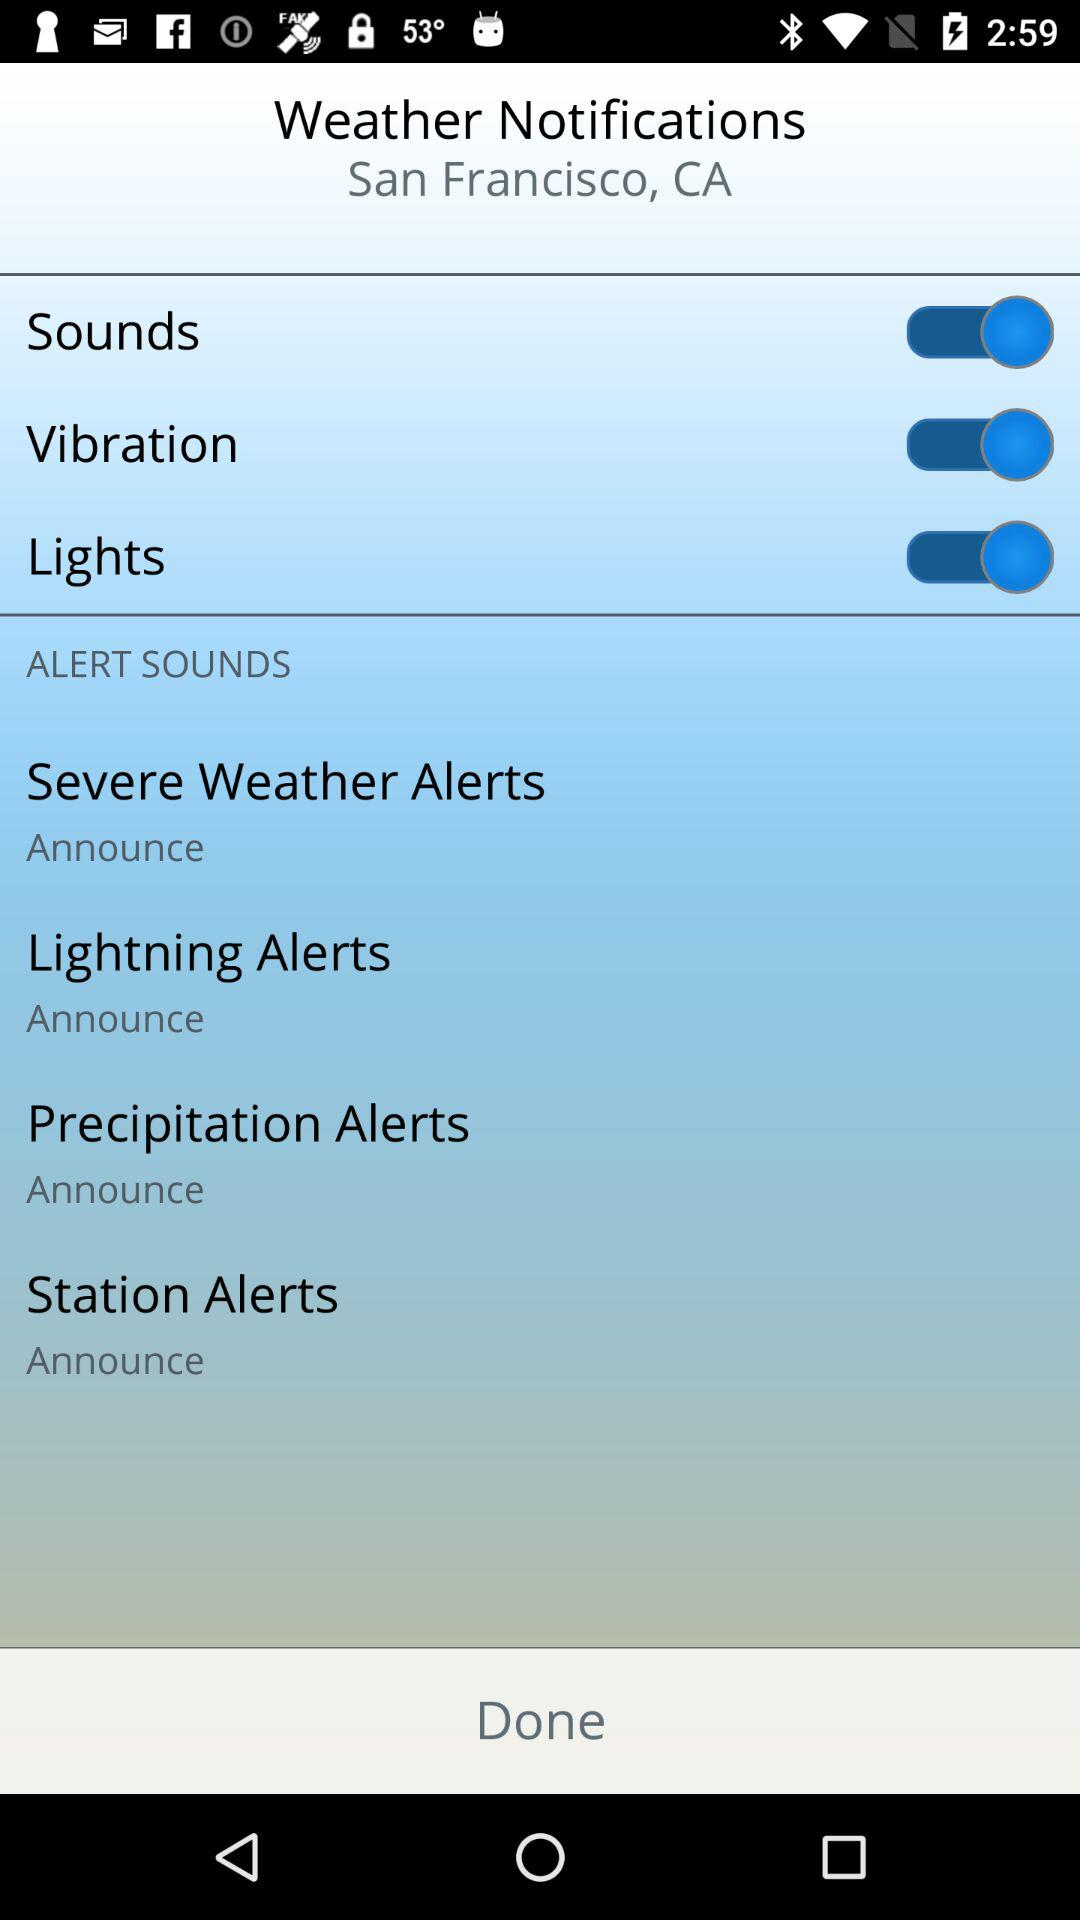What is the given location? The given location is San Francisco, CA. 